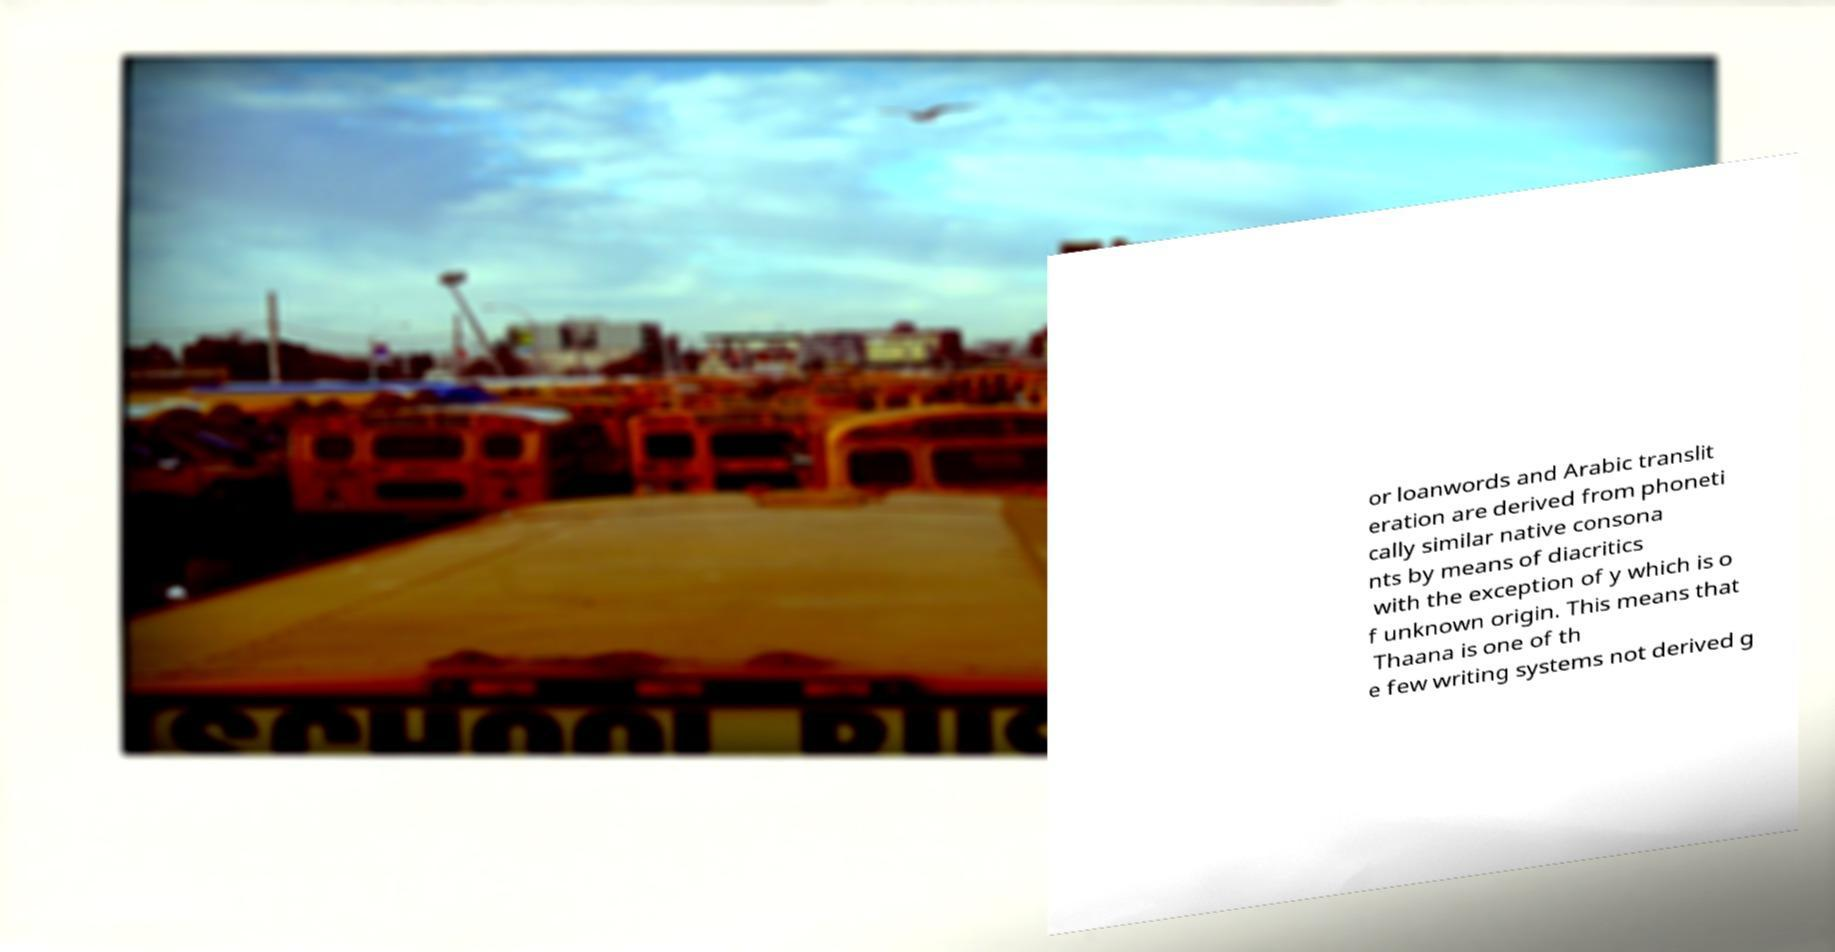There's text embedded in this image that I need extracted. Can you transcribe it verbatim? or loanwords and Arabic translit eration are derived from phoneti cally similar native consona nts by means of diacritics with the exception of y which is o f unknown origin. This means that Thaana is one of th e few writing systems not derived g 